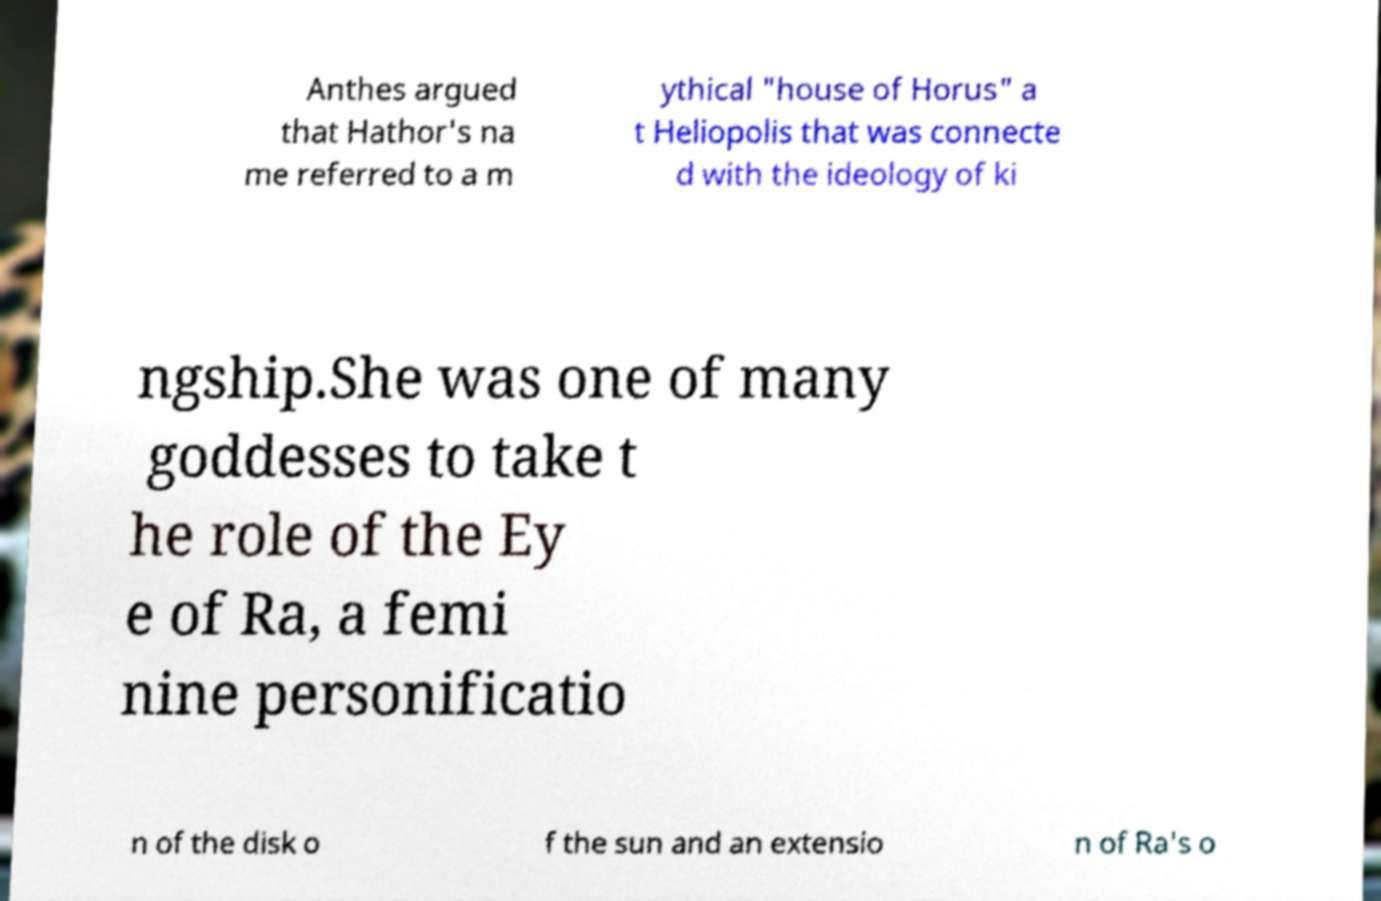Could you assist in decoding the text presented in this image and type it out clearly? Anthes argued that Hathor's na me referred to a m ythical "house of Horus" a t Heliopolis that was connecte d with the ideology of ki ngship.She was one of many goddesses to take t he role of the Ey e of Ra, a femi nine personificatio n of the disk o f the sun and an extensio n of Ra's o 